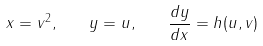<formula> <loc_0><loc_0><loc_500><loc_500>x = v ^ { 2 } , \quad y = u , \quad \frac { d y } { d x } = h ( u , v )</formula> 